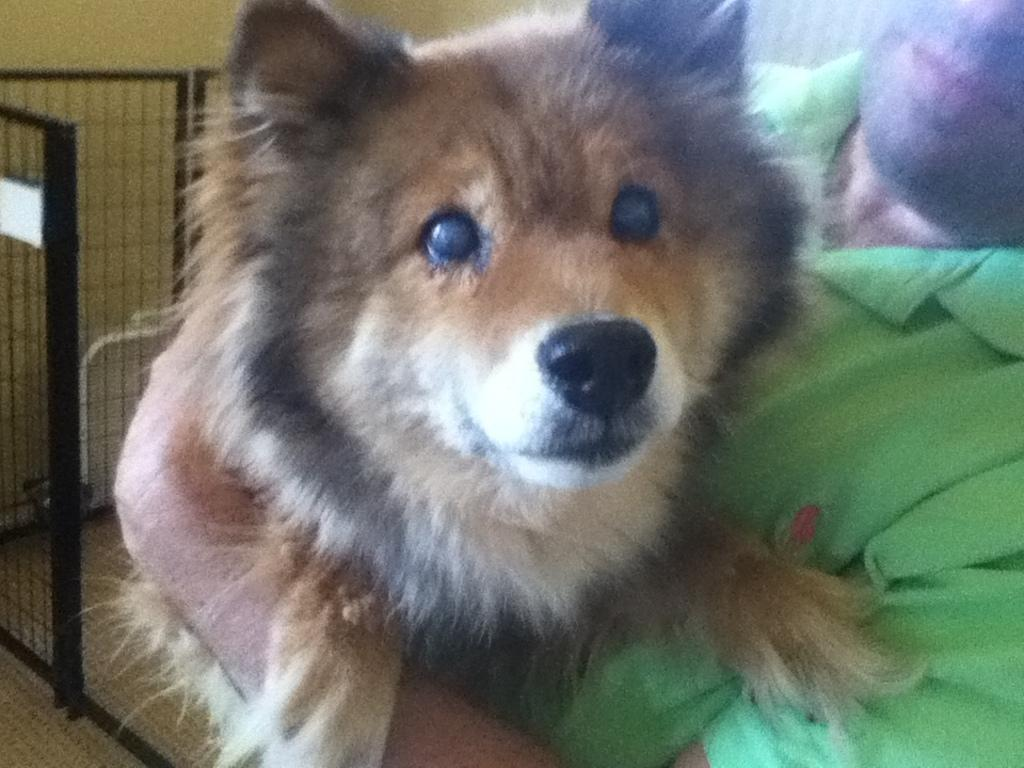Who is present in the image? There is a man in the image. What is the man wearing? The man is wearing a green t-shirt. What is the man holding in the image? The man is holding a dog. What can be seen in the background of the image? There is fencing visible in the background of the image. What type of breakfast is the man eating in the image? There is no breakfast present in the image; the man is holding a dog. 